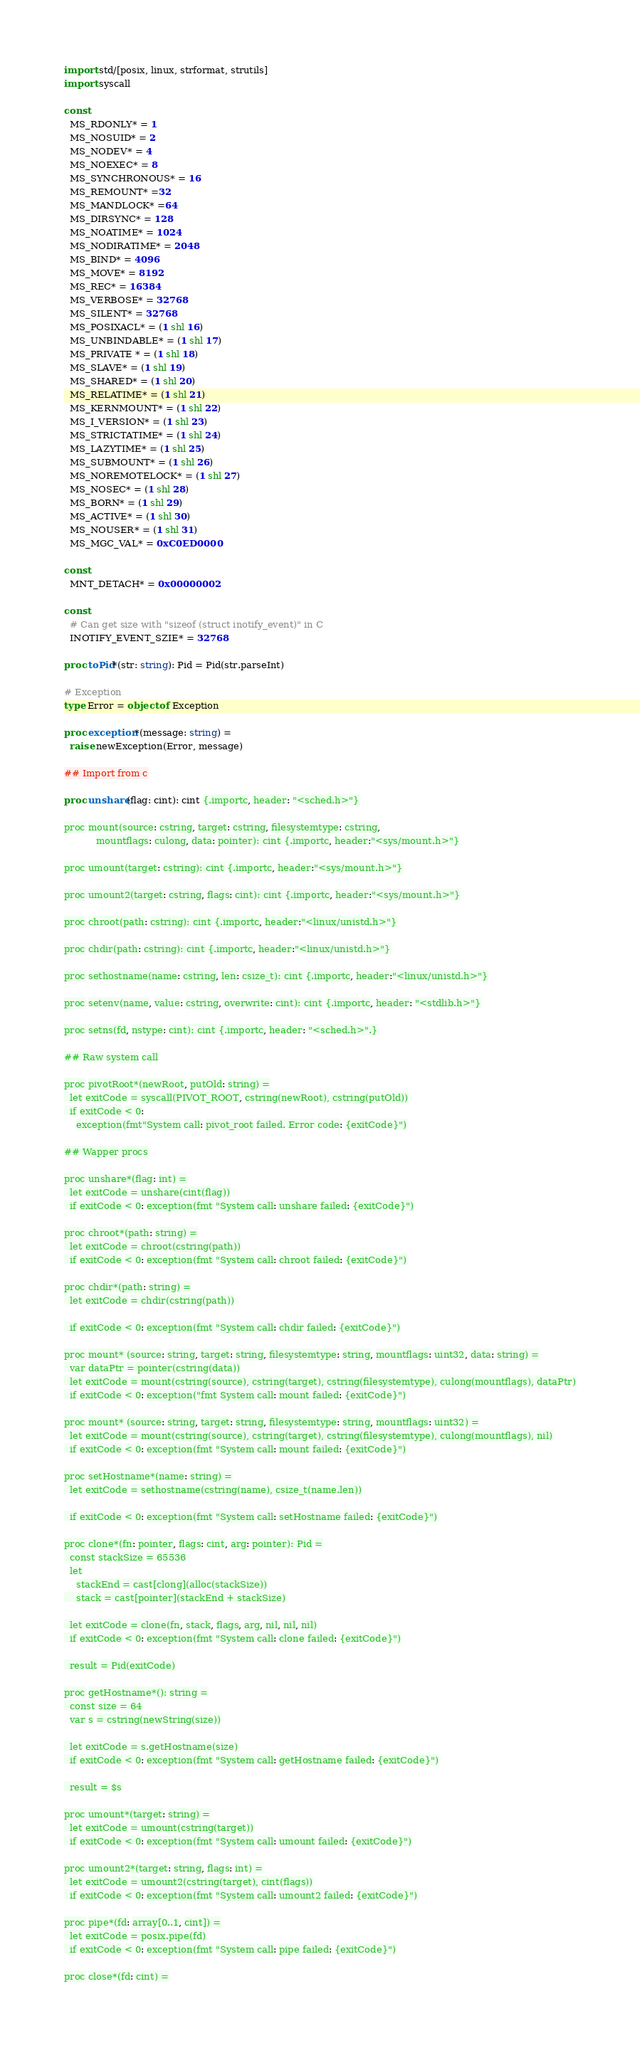Convert code to text. <code><loc_0><loc_0><loc_500><loc_500><_Nim_>import std/[posix, linux, strformat, strutils]
import syscall

const
  MS_RDONLY* = 1
  MS_NOSUID* = 2
  MS_NODEV* = 4
  MS_NOEXEC* = 8
  MS_SYNCHRONOUS* = 16
  MS_REMOUNT* =32
  MS_MANDLOCK* =64
  MS_DIRSYNC* = 128
  MS_NOATIME* = 1024
  MS_NODIRATIME* = 2048
  MS_BIND* = 4096
  MS_MOVE* = 8192
  MS_REC* = 16384
  MS_VERBOSE* = 32768
  MS_SILENT* = 32768
  MS_POSIXACL* = (1 shl 16)
  MS_UNBINDABLE* = (1 shl 17)
  MS_PRIVATE * = (1 shl 18)
  MS_SLAVE* = (1 shl 19)
  MS_SHARED* = (1 shl 20)
  MS_RELATIME* = (1 shl 21)
  MS_KERNMOUNT* = (1 shl 22)
  MS_I_VERSION* = (1 shl 23)
  MS_STRICTATIME* = (1 shl 24)
  MS_LAZYTIME* = (1 shl 25)
  MS_SUBMOUNT* = (1 shl 26)
  MS_NOREMOTELOCK* = (1 shl 27)
  MS_NOSEC* = (1 shl 28)
  MS_BORN* = (1 shl 29)
  MS_ACTIVE* = (1 shl 30)
  MS_NOUSER* = (1 shl 31)
  MS_MGC_VAL* = 0xC0ED0000

const
  MNT_DETACH* = 0x00000002

const
  # Can get size with "sizeof (struct inotify_event)" in C
  INOTIFY_EVENT_SZIE* = 32768

proc toPid*(str: string): Pid = Pid(str.parseInt)

# Exception
type Error = object of Exception

proc exception*(message: string) =
  raise newException(Error, message)

## Import from c

proc unshare(flag: cint): cint {.importc, header: "<sched.h>"}

proc mount(source: cstring, target: cstring, filesystemtype: cstring,
           mountflags: culong, data: pointer): cint {.importc, header:"<sys/mount.h>"}

proc umount(target: cstring): cint {.importc, header:"<sys/mount.h>"}

proc umount2(target: cstring, flags: cint): cint {.importc, header:"<sys/mount.h>"}

proc chroot(path: cstring): cint {.importc, header:"<linux/unistd.h>"}

proc chdir(path: cstring): cint {.importc, header:"<linux/unistd.h>"}

proc sethostname(name: cstring, len: csize_t): cint {.importc, header:"<linux/unistd.h>"}

proc setenv(name, value: cstring, overwrite: cint): cint {.importc, header: "<stdlib.h>"}

proc setns(fd, nstype: cint): cint {.importc, header: "<sched.h>".}

## Raw system call

proc pivotRoot*(newRoot, putOld: string) =
  let exitCode = syscall(PIVOT_ROOT, cstring(newRoot), cstring(putOld))
  if exitCode < 0:
    exception(fmt"System call: pivot_root failed. Error code: {exitCode}")

## Wapper procs

proc unshare*(flag: int) =
  let exitCode = unshare(cint(flag))
  if exitCode < 0: exception(fmt "System call: unshare failed: {exitCode}")

proc chroot*(path: string) =
  let exitCode = chroot(cstring(path))
  if exitCode < 0: exception(fmt "System call: chroot failed: {exitCode}")

proc chdir*(path: string) =
  let exitCode = chdir(cstring(path))

  if exitCode < 0: exception(fmt "System call: chdir failed: {exitCode}")

proc mount* (source: string, target: string, filesystemtype: string, mountflags: uint32, data: string) =
  var dataPtr = pointer(cstring(data))
  let exitCode = mount(cstring(source), cstring(target), cstring(filesystemtype), culong(mountflags), dataPtr)
  if exitCode < 0: exception("fmt System call: mount failed: {exitCode}")

proc mount* (source: string, target: string, filesystemtype: string, mountflags: uint32) =
  let exitCode = mount(cstring(source), cstring(target), cstring(filesystemtype), culong(mountflags), nil)
  if exitCode < 0: exception(fmt "System call: mount failed: {exitCode}")

proc setHostname*(name: string) =
  let exitCode = sethostname(cstring(name), csize_t(name.len))

  if exitCode < 0: exception(fmt "System call: setHostname failed: {exitCode}")

proc clone*(fn: pointer, flags: cint, arg: pointer): Pid =
  const stackSize = 65536
  let
    stackEnd = cast[clong](alloc(stackSize))
    stack = cast[pointer](stackEnd + stackSize)

  let exitCode = clone(fn, stack, flags, arg, nil, nil, nil)
  if exitCode < 0: exception(fmt "System call: clone failed: {exitCode}")

  result = Pid(exitCode)

proc getHostname*(): string =
  const size = 64
  var s = cstring(newString(size))

  let exitCode = s.getHostname(size)
  if exitCode < 0: exception(fmt "System call: getHostname failed: {exitCode}")

  result = $s

proc umount*(target: string) =
  let exitCode = umount(cstring(target))
  if exitCode < 0: exception(fmt "System call: umount failed: {exitCode}")

proc umount2*(target: string, flags: int) =
  let exitCode = umount2(cstring(target), cint(flags))
  if exitCode < 0: exception(fmt "System call: umount2 failed: {exitCode}")

proc pipe*(fd: array[0..1, cint]) =
  let exitCode = posix.pipe(fd)
  if exitCode < 0: exception(fmt "System call: pipe failed: {exitCode}")

proc close*(fd: cint) =</code> 